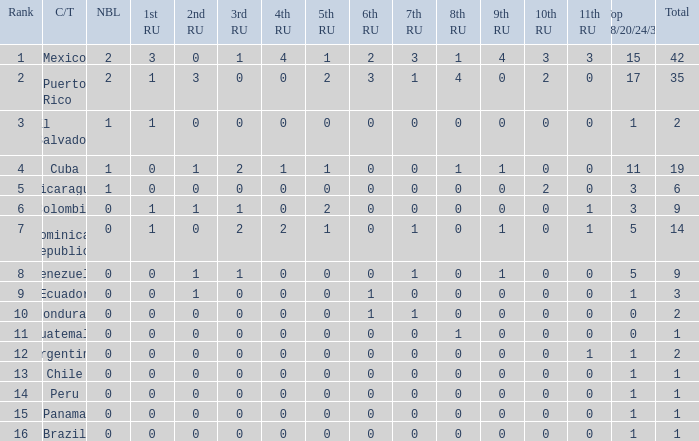What is the 9th runner-up with a top 18/20/24/30 greater than 17 and a 5th runner-up of 2? None. 